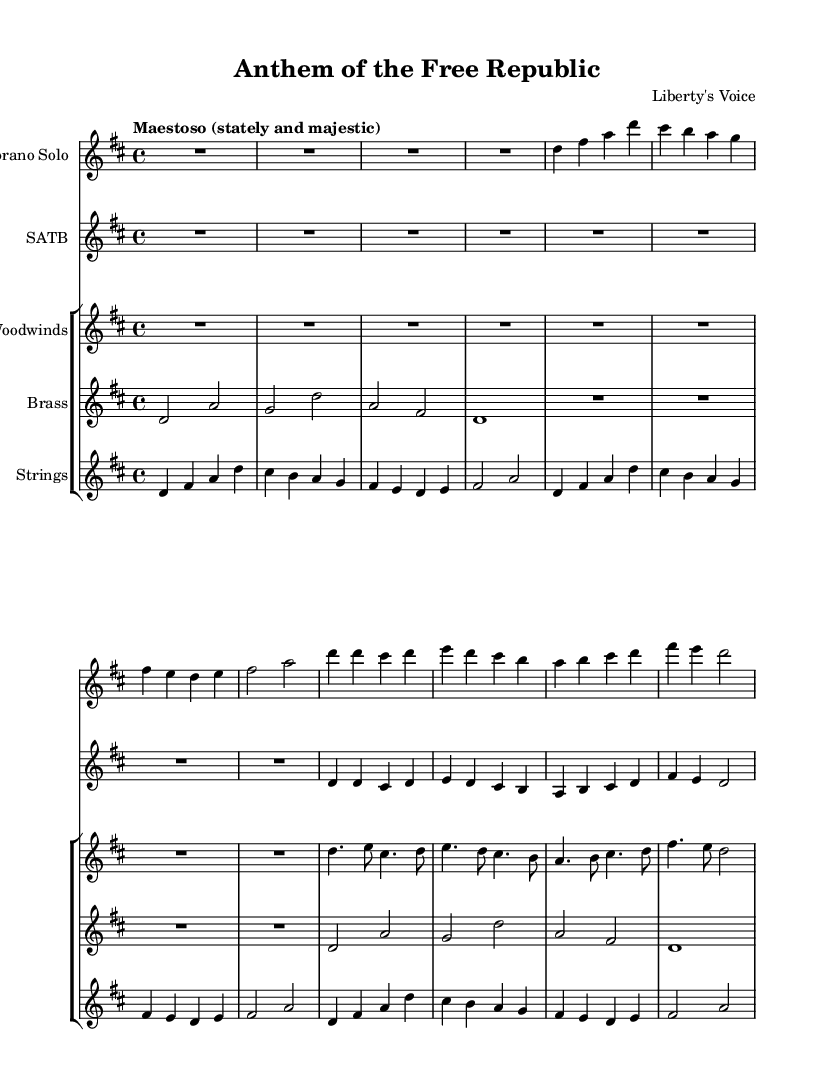What is the key signature of this music? The key signature appears in the global section at the beginning of the code, indicating it is D major, which has two sharps (F# and C#).
Answer: D major What is the time signature of this piece? The time signature is indicated in the global section of the code as 4/4, meaning there are four beats in a measure and the quarter note gets one beat.
Answer: 4/4 What tempo indication is given for the music? The code specifies the tempo as "Maestoso (stately and majestic)" in the global section, which tells the performer to play the music slowly and stately.
Answer: Maestoso How many verses are indicated in the music? The score indicates one complete introduction followed by two distinct sections labeled as Verse 1 and a Chorus. Since Verse 1 is drawn from the same material, it is treated as a singular verse within the structure.
Answer: 1 Which instruments are featured in this composition? The composition includes a soprano solo, SATB choir, woodwinds, brass, and strings, as indicated in the score layout section where each instrument group is listed.
Answer: Soprano Solo, SATB Choir, Woodwinds, Brass, Strings What musical forms can be identified in the composition? The structure of the composition consists of an introduction, a verse, and a chorus, as denoted in the music sections described in the score, indicating a clear instance of verse-chorus form.
Answer: Verse-Chorus Which sections are repeated in the music? The score shows that the chorus section is repeated, as the same musical lines are used in both the choir and the woodwind sections for the chorus, emphasizing its thematic significance.
Answer: Chorus 